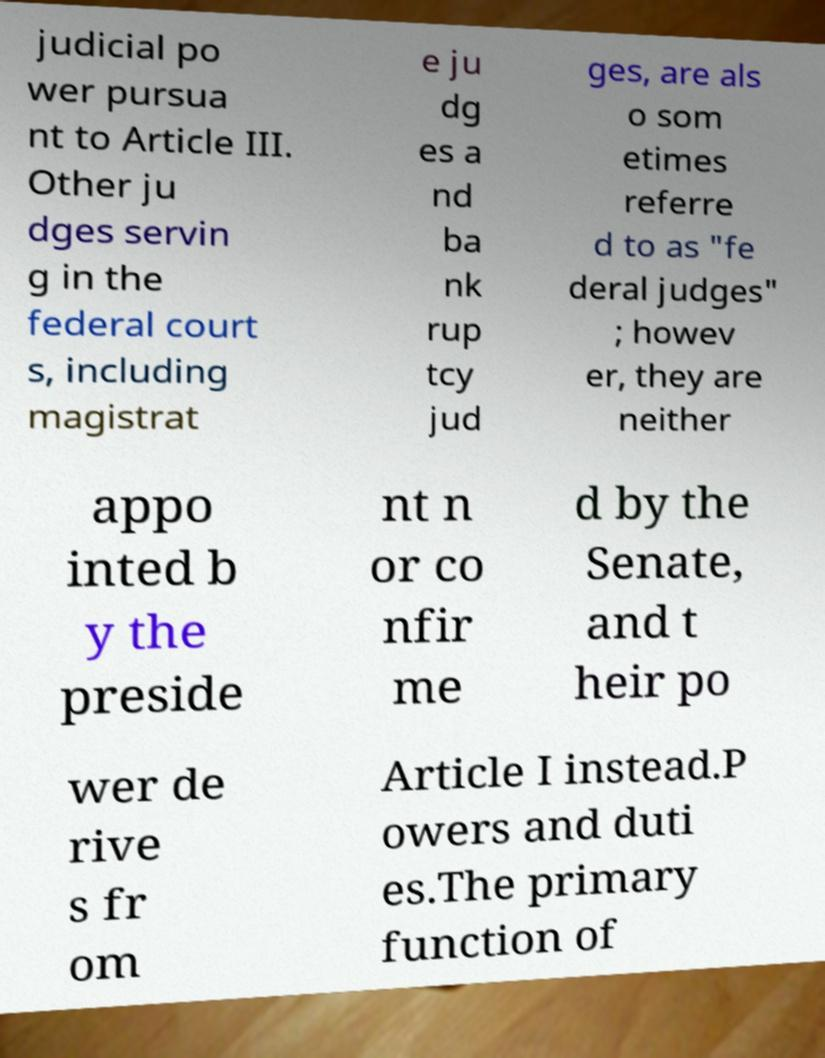Could you assist in decoding the text presented in this image and type it out clearly? judicial po wer pursua nt to Article III. Other ju dges servin g in the federal court s, including magistrat e ju dg es a nd ba nk rup tcy jud ges, are als o som etimes referre d to as "fe deral judges" ; howev er, they are neither appo inted b y the preside nt n or co nfir me d by the Senate, and t heir po wer de rive s fr om Article I instead.P owers and duti es.The primary function of 